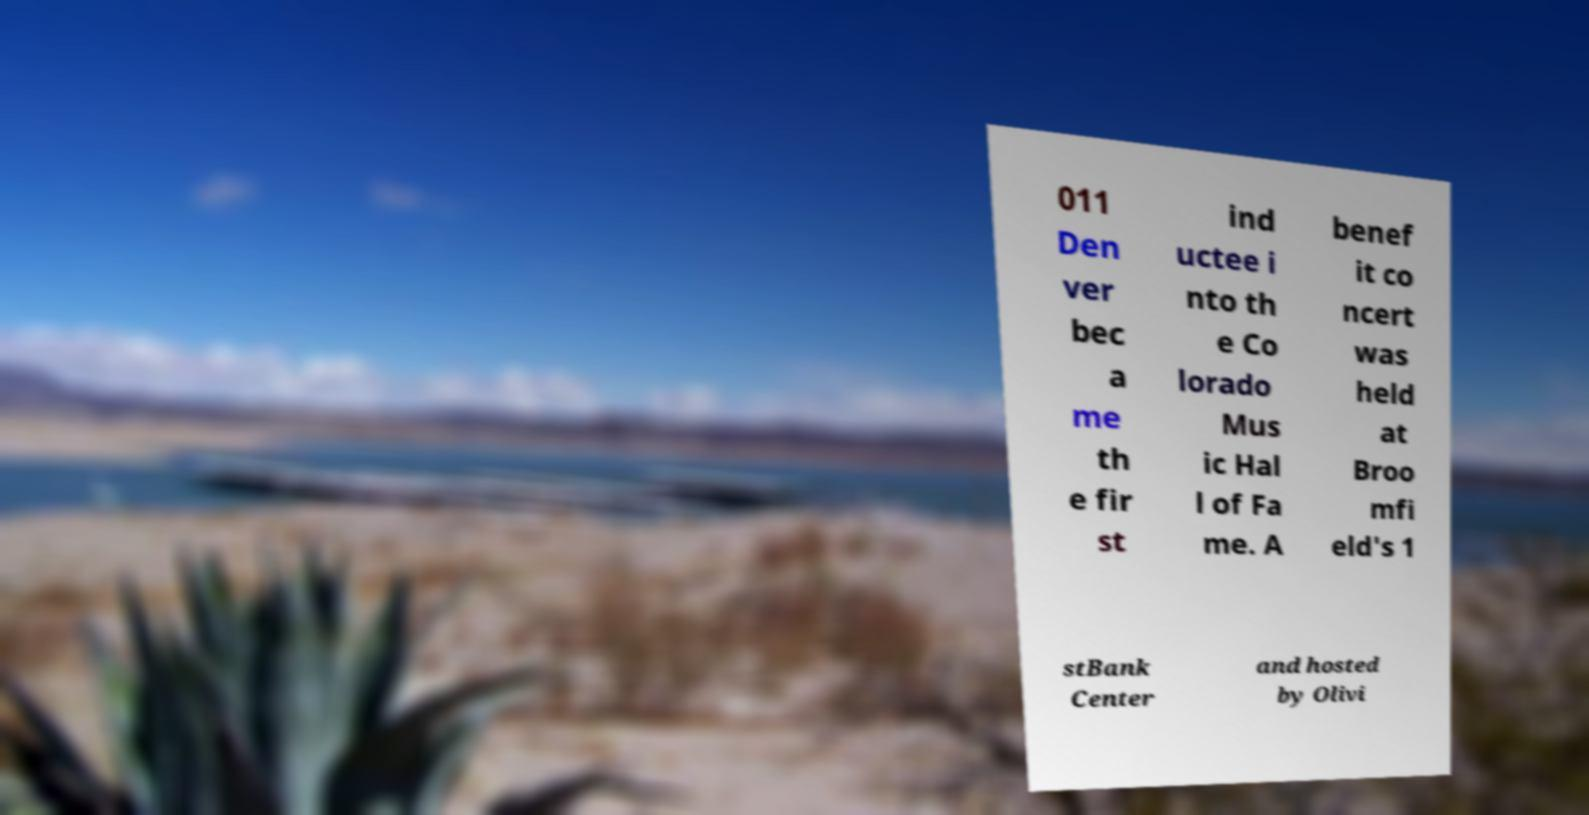What messages or text are displayed in this image? I need them in a readable, typed format. 011 Den ver bec a me th e fir st ind uctee i nto th e Co lorado Mus ic Hal l of Fa me. A benef it co ncert was held at Broo mfi eld's 1 stBank Center and hosted by Olivi 